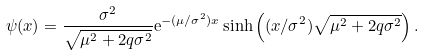Convert formula to latex. <formula><loc_0><loc_0><loc_500><loc_500>\psi ( x ) = \frac { \sigma ^ { 2 } } { \sqrt { \mu ^ { 2 } + 2 q \sigma ^ { 2 } } } \mathrm e ^ { - ( \mu / \sigma ^ { 2 } ) x } \sinh \left ( ( x / \sigma ^ { 2 } ) \sqrt { \mu ^ { 2 } + 2 q \sigma ^ { 2 } } \right ) .</formula> 